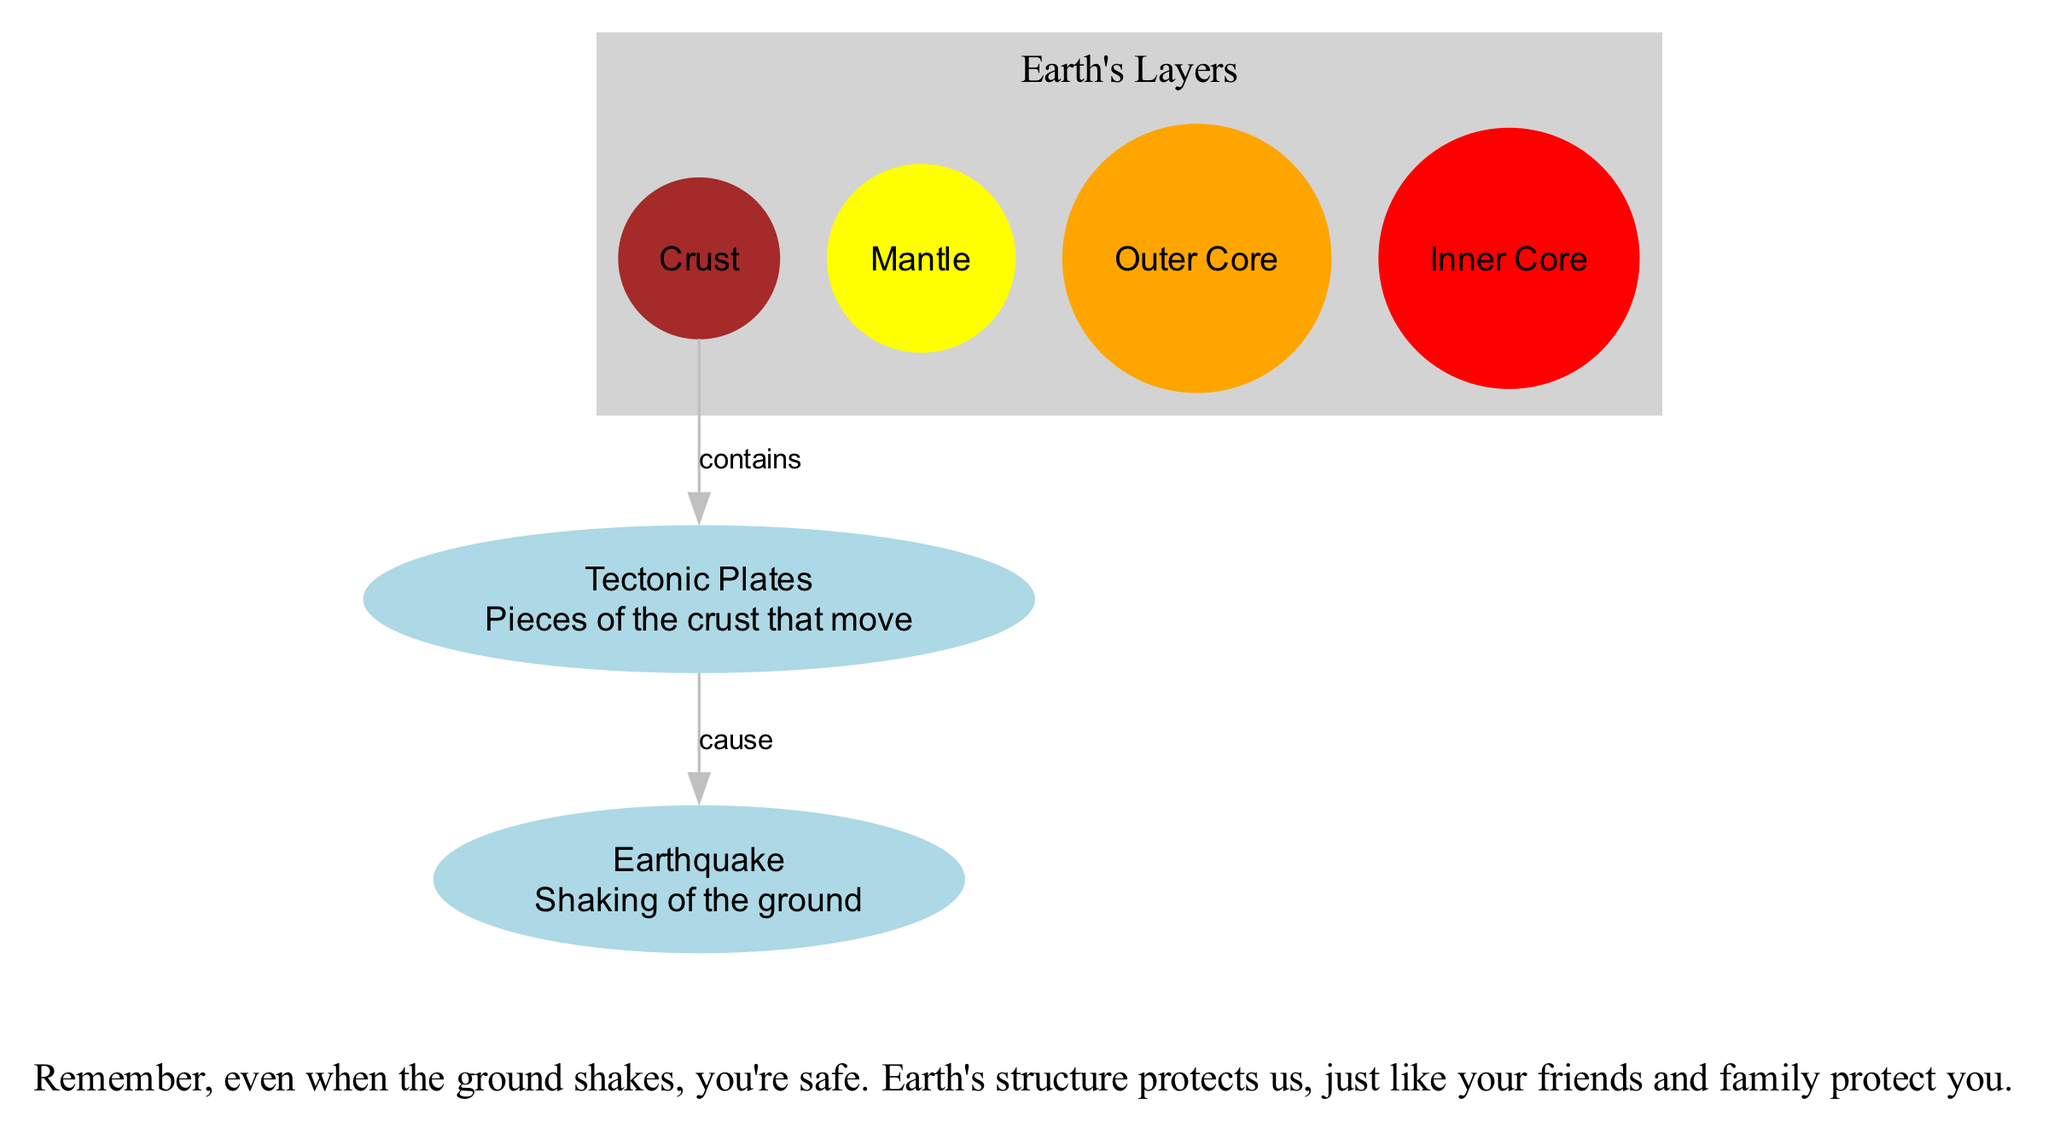What is the outermost layer of the Earth? The diagram labels the different layers of the Earth, and the one at the top is labeled "Crust," indicating it is the outermost layer.
Answer: Crust How many main layers of the Earth are shown in the diagram? The nodes representing the Earth’s layers include the Crust, Mantle, Outer Core, and Inner Core. Counting these four layers gives us a total of four main layers.
Answer: 4 What do tectonic plates cause? The diagram illustrates a directed edge from "Tectonic Plates" to "Earthquake" labeled "cause," indicating that tectonic plates are responsible for causing earthquakes.
Answer: Earthquake What is the state of the Inner Core? The diagram specifies that the Inner Core is a "Solid center of the Earth," which informs us of its physical state being solid.
Answer: Solid How does the Crust relate to tectonic plates? The diagram shows an edge labeled "contains" from Crust to Tectonic Plates, indicating that the crust is where the tectonic plates exist, relating the two layers.
Answer: contains What material is the Outer Core made of? The description for the Outer Core states that it is a "Liquid layer of iron and nickel," which tells us what materials comprise this layer of the Earth.
Answer: iron and nickel What color represents the Mantle in the diagram? The nodes in the diagram are color-coded, and the Mantle is indicated to be "yellow," signifying its assigned color.
Answer: yellow What relationship does tectonic plates have with earthquakes in the diagram? The diagram connects tectonic plates with earthquakes through a directed edge labeled "cause," indicating that the movement or activity of tectonic plates is the reason for earthquakes happening.
Answer: cause What layer is directly below the Crust? Based on the arrangement in the diagram, the Mantle is depicted directly below the Crust, establishing their positioning in Earth’s structure.
Answer: Mantle 